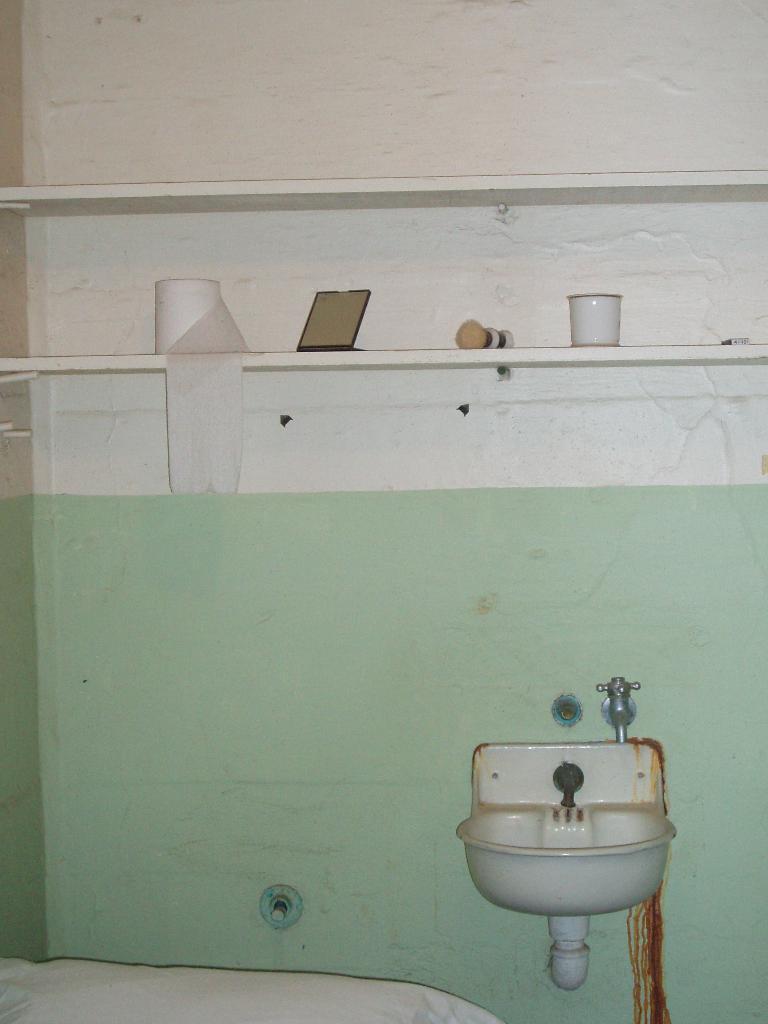Describe this image in one or two sentences. In this image I can see white colour sink and water tap. On this rack I can see a tissue roll, a mirror, a brush and a white colour mug. 